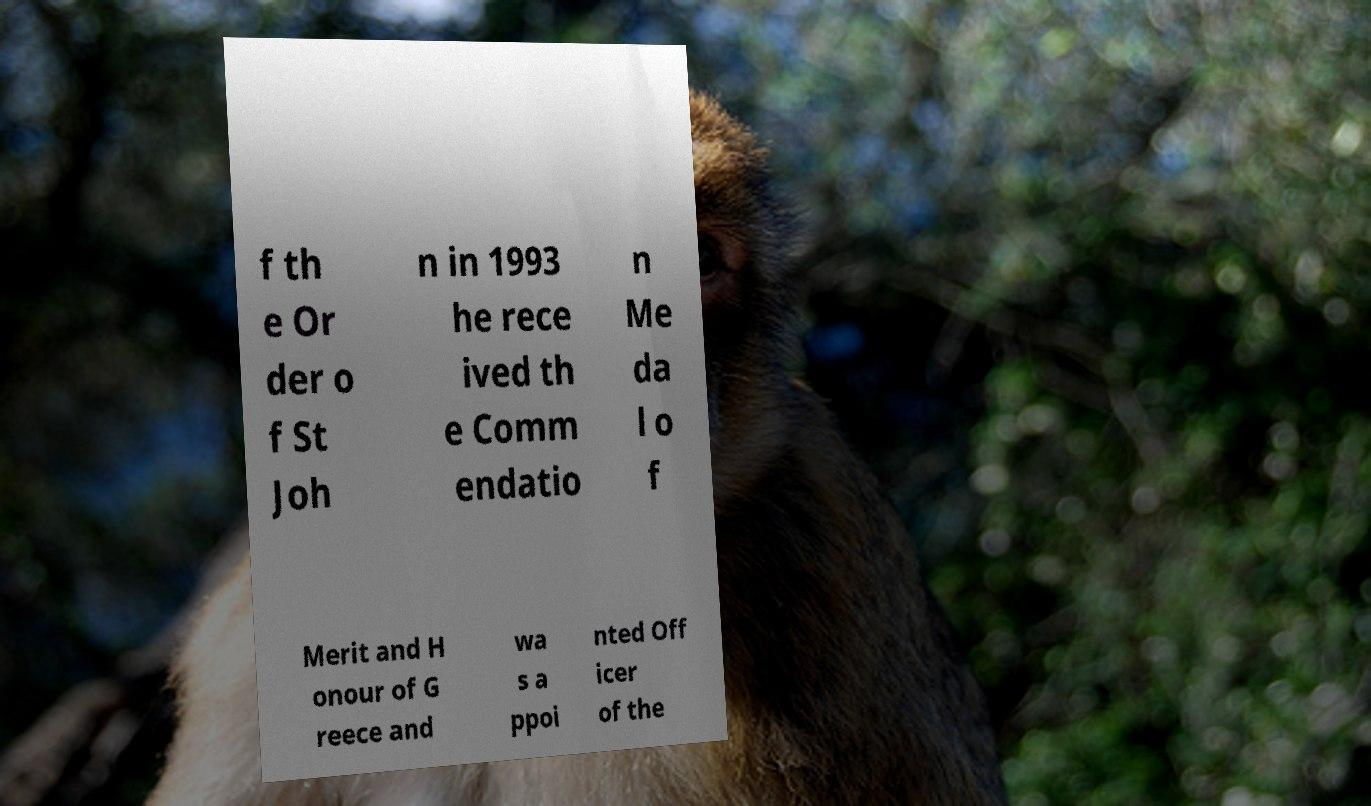There's text embedded in this image that I need extracted. Can you transcribe it verbatim? f th e Or der o f St Joh n in 1993 he rece ived th e Comm endatio n Me da l o f Merit and H onour of G reece and wa s a ppoi nted Off icer of the 